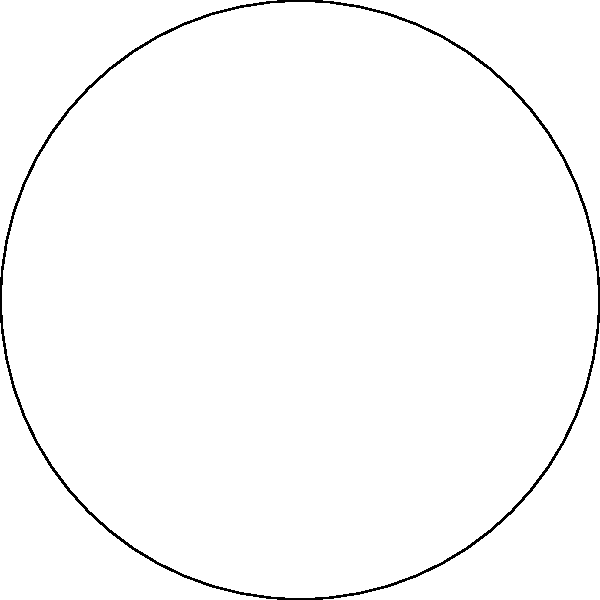In your pie-shaped herb garden, you've created a sector with a central angle of 120° and a radius of 5 meters. Calculate the area of this sector where you plan to grow Himalayan herbs. Round your answer to two decimal places. To calculate the area of a sector, we'll follow these steps:

1) The formula for the area of a sector is:

   $$A = \frac{\theta}{360°} \pi r^2$$

   Where $\theta$ is the central angle in degrees, and $r$ is the radius.

2) We're given:
   $\theta = 120°$
   $r = 5$ meters

3) Let's substitute these values into our formula:

   $$A = \frac{120°}{360°} \pi (5\text{ m})^2$$

4) Simplify:
   $$A = \frac{1}{3} \pi (25\text{ m}^2)$$

5) Calculate:
   $$A = \frac{1}{3} \times 3.14159... \times 25\text{ m}^2$$
   $$A \approx 26.18\text{ m}^2$$

6) Rounding to two decimal places:
   $$A \approx 26.18\text{ m}^2$$

Thus, the area of your Himalayan herb sector is approximately 26.18 square meters.
Answer: 26.18 m² 